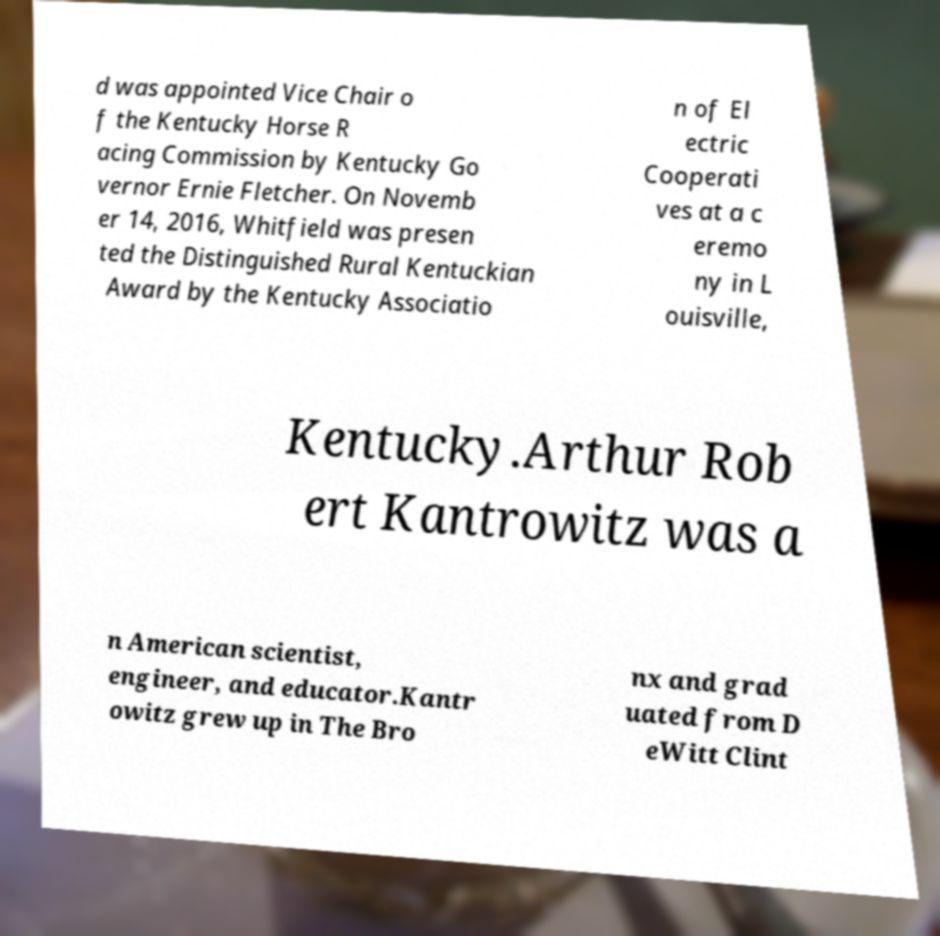Please identify and transcribe the text found in this image. d was appointed Vice Chair o f the Kentucky Horse R acing Commission by Kentucky Go vernor Ernie Fletcher. On Novemb er 14, 2016, Whitfield was presen ted the Distinguished Rural Kentuckian Award by the Kentucky Associatio n of El ectric Cooperati ves at a c eremo ny in L ouisville, Kentucky.Arthur Rob ert Kantrowitz was a n American scientist, engineer, and educator.Kantr owitz grew up in The Bro nx and grad uated from D eWitt Clint 